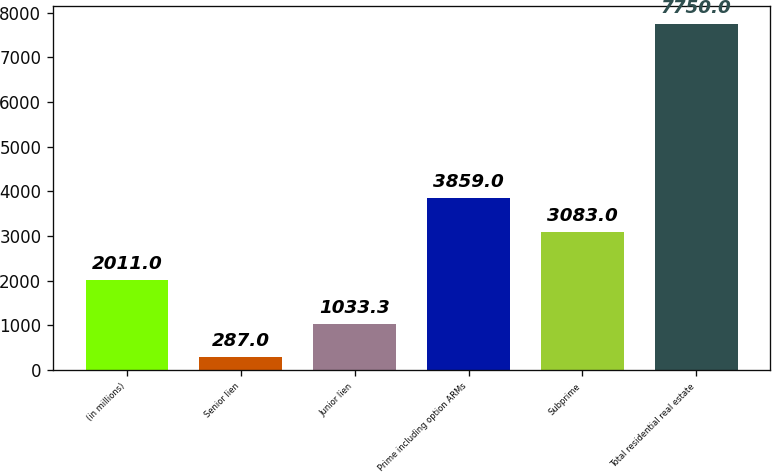<chart> <loc_0><loc_0><loc_500><loc_500><bar_chart><fcel>(in millions)<fcel>Senior lien<fcel>Junior lien<fcel>Prime including option ARMs<fcel>Subprime<fcel>Total residential real estate<nl><fcel>2011<fcel>287<fcel>1033.3<fcel>3859<fcel>3083<fcel>7750<nl></chart> 